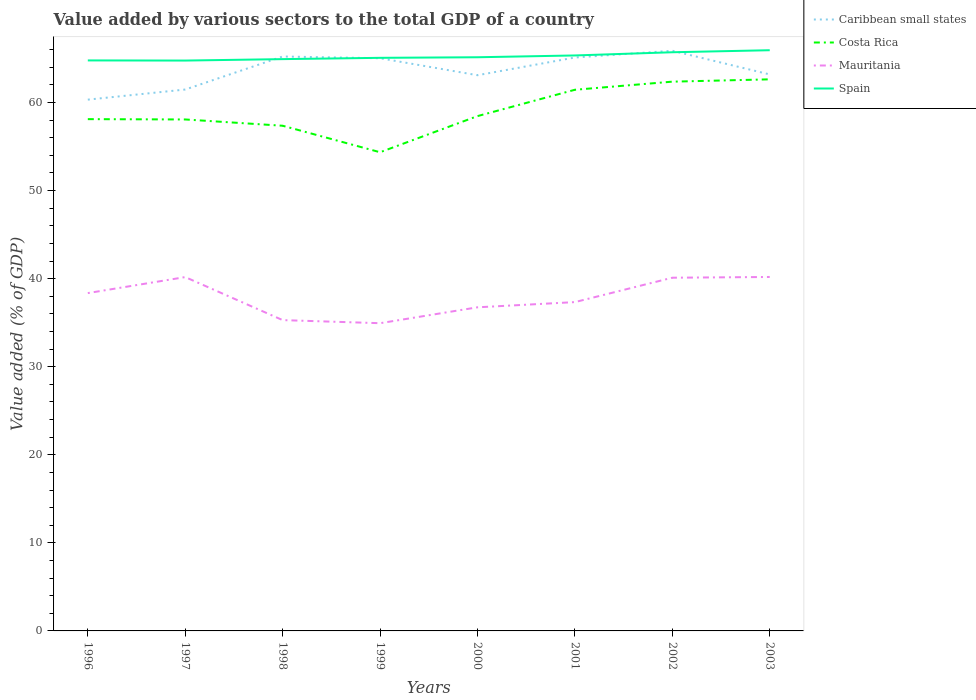How many different coloured lines are there?
Make the answer very short. 4. Is the number of lines equal to the number of legend labels?
Your answer should be compact. Yes. Across all years, what is the maximum value added by various sectors to the total GDP in Mauritania?
Provide a succinct answer. 34.94. In which year was the value added by various sectors to the total GDP in Caribbean small states maximum?
Make the answer very short. 1996. What is the total value added by various sectors to the total GDP in Spain in the graph?
Your answer should be compact. -0.86. What is the difference between the highest and the second highest value added by various sectors to the total GDP in Caribbean small states?
Make the answer very short. 5.55. Is the value added by various sectors to the total GDP in Costa Rica strictly greater than the value added by various sectors to the total GDP in Mauritania over the years?
Provide a succinct answer. No. How many lines are there?
Your answer should be very brief. 4. How many years are there in the graph?
Your answer should be compact. 8. What is the difference between two consecutive major ticks on the Y-axis?
Keep it short and to the point. 10. Does the graph contain any zero values?
Your answer should be very brief. No. How many legend labels are there?
Provide a short and direct response. 4. What is the title of the graph?
Keep it short and to the point. Value added by various sectors to the total GDP of a country. Does "Sub-Saharan Africa (all income levels)" appear as one of the legend labels in the graph?
Give a very brief answer. No. What is the label or title of the Y-axis?
Offer a very short reply. Value added (% of GDP). What is the Value added (% of GDP) of Caribbean small states in 1996?
Offer a terse response. 60.33. What is the Value added (% of GDP) of Costa Rica in 1996?
Offer a very short reply. 58.12. What is the Value added (% of GDP) of Mauritania in 1996?
Offer a terse response. 38.36. What is the Value added (% of GDP) in Spain in 1996?
Provide a short and direct response. 64.78. What is the Value added (% of GDP) in Caribbean small states in 1997?
Your answer should be compact. 61.48. What is the Value added (% of GDP) of Costa Rica in 1997?
Your answer should be compact. 58.08. What is the Value added (% of GDP) of Mauritania in 1997?
Provide a short and direct response. 40.18. What is the Value added (% of GDP) in Spain in 1997?
Give a very brief answer. 64.77. What is the Value added (% of GDP) of Caribbean small states in 1998?
Your answer should be very brief. 65.23. What is the Value added (% of GDP) of Costa Rica in 1998?
Provide a short and direct response. 57.37. What is the Value added (% of GDP) in Mauritania in 1998?
Provide a succinct answer. 35.29. What is the Value added (% of GDP) in Spain in 1998?
Keep it short and to the point. 64.93. What is the Value added (% of GDP) of Caribbean small states in 1999?
Your response must be concise. 65.03. What is the Value added (% of GDP) of Costa Rica in 1999?
Your answer should be compact. 54.36. What is the Value added (% of GDP) of Mauritania in 1999?
Your answer should be very brief. 34.94. What is the Value added (% of GDP) in Spain in 1999?
Ensure brevity in your answer.  65.08. What is the Value added (% of GDP) in Caribbean small states in 2000?
Offer a terse response. 63.1. What is the Value added (% of GDP) in Costa Rica in 2000?
Your answer should be compact. 58.46. What is the Value added (% of GDP) of Mauritania in 2000?
Offer a terse response. 36.75. What is the Value added (% of GDP) in Spain in 2000?
Your answer should be very brief. 65.14. What is the Value added (% of GDP) in Caribbean small states in 2001?
Offer a terse response. 65.11. What is the Value added (% of GDP) of Costa Rica in 2001?
Provide a short and direct response. 61.45. What is the Value added (% of GDP) of Mauritania in 2001?
Offer a terse response. 37.34. What is the Value added (% of GDP) of Spain in 2001?
Your answer should be very brief. 65.35. What is the Value added (% of GDP) in Caribbean small states in 2002?
Ensure brevity in your answer.  65.88. What is the Value added (% of GDP) in Costa Rica in 2002?
Your answer should be compact. 62.37. What is the Value added (% of GDP) of Mauritania in 2002?
Your answer should be compact. 40.11. What is the Value added (% of GDP) in Spain in 2002?
Your response must be concise. 65.71. What is the Value added (% of GDP) in Caribbean small states in 2003?
Offer a very short reply. 63.19. What is the Value added (% of GDP) in Costa Rica in 2003?
Your answer should be compact. 62.64. What is the Value added (% of GDP) in Mauritania in 2003?
Offer a terse response. 40.19. What is the Value added (% of GDP) of Spain in 2003?
Offer a very short reply. 65.94. Across all years, what is the maximum Value added (% of GDP) in Caribbean small states?
Your answer should be compact. 65.88. Across all years, what is the maximum Value added (% of GDP) in Costa Rica?
Offer a terse response. 62.64. Across all years, what is the maximum Value added (% of GDP) of Mauritania?
Your response must be concise. 40.19. Across all years, what is the maximum Value added (% of GDP) of Spain?
Your answer should be very brief. 65.94. Across all years, what is the minimum Value added (% of GDP) in Caribbean small states?
Offer a terse response. 60.33. Across all years, what is the minimum Value added (% of GDP) of Costa Rica?
Give a very brief answer. 54.36. Across all years, what is the minimum Value added (% of GDP) of Mauritania?
Give a very brief answer. 34.94. Across all years, what is the minimum Value added (% of GDP) in Spain?
Provide a short and direct response. 64.77. What is the total Value added (% of GDP) in Caribbean small states in the graph?
Provide a short and direct response. 509.36. What is the total Value added (% of GDP) in Costa Rica in the graph?
Offer a terse response. 472.83. What is the total Value added (% of GDP) in Mauritania in the graph?
Provide a short and direct response. 303.17. What is the total Value added (% of GDP) of Spain in the graph?
Provide a succinct answer. 521.7. What is the difference between the Value added (% of GDP) of Caribbean small states in 1996 and that in 1997?
Provide a succinct answer. -1.15. What is the difference between the Value added (% of GDP) in Costa Rica in 1996 and that in 1997?
Your answer should be compact. 0.04. What is the difference between the Value added (% of GDP) in Mauritania in 1996 and that in 1997?
Provide a short and direct response. -1.82. What is the difference between the Value added (% of GDP) in Spain in 1996 and that in 1997?
Your response must be concise. 0.02. What is the difference between the Value added (% of GDP) in Caribbean small states in 1996 and that in 1998?
Keep it short and to the point. -4.9. What is the difference between the Value added (% of GDP) in Costa Rica in 1996 and that in 1998?
Your answer should be very brief. 0.75. What is the difference between the Value added (% of GDP) in Mauritania in 1996 and that in 1998?
Ensure brevity in your answer.  3.07. What is the difference between the Value added (% of GDP) in Spain in 1996 and that in 1998?
Your response must be concise. -0.15. What is the difference between the Value added (% of GDP) in Caribbean small states in 1996 and that in 1999?
Provide a succinct answer. -4.7. What is the difference between the Value added (% of GDP) of Costa Rica in 1996 and that in 1999?
Keep it short and to the point. 3.76. What is the difference between the Value added (% of GDP) of Mauritania in 1996 and that in 1999?
Ensure brevity in your answer.  3.42. What is the difference between the Value added (% of GDP) in Spain in 1996 and that in 1999?
Keep it short and to the point. -0.29. What is the difference between the Value added (% of GDP) of Caribbean small states in 1996 and that in 2000?
Offer a terse response. -2.77. What is the difference between the Value added (% of GDP) in Costa Rica in 1996 and that in 2000?
Make the answer very short. -0.34. What is the difference between the Value added (% of GDP) of Mauritania in 1996 and that in 2000?
Make the answer very short. 1.61. What is the difference between the Value added (% of GDP) of Spain in 1996 and that in 2000?
Make the answer very short. -0.36. What is the difference between the Value added (% of GDP) of Caribbean small states in 1996 and that in 2001?
Ensure brevity in your answer.  -4.78. What is the difference between the Value added (% of GDP) in Costa Rica in 1996 and that in 2001?
Your response must be concise. -3.34. What is the difference between the Value added (% of GDP) of Spain in 1996 and that in 2001?
Make the answer very short. -0.56. What is the difference between the Value added (% of GDP) in Caribbean small states in 1996 and that in 2002?
Your answer should be very brief. -5.55. What is the difference between the Value added (% of GDP) in Costa Rica in 1996 and that in 2002?
Offer a terse response. -4.26. What is the difference between the Value added (% of GDP) of Mauritania in 1996 and that in 2002?
Provide a short and direct response. -1.75. What is the difference between the Value added (% of GDP) in Spain in 1996 and that in 2002?
Give a very brief answer. -0.93. What is the difference between the Value added (% of GDP) of Caribbean small states in 1996 and that in 2003?
Give a very brief answer. -2.86. What is the difference between the Value added (% of GDP) in Costa Rica in 1996 and that in 2003?
Keep it short and to the point. -4.52. What is the difference between the Value added (% of GDP) in Mauritania in 1996 and that in 2003?
Make the answer very short. -1.83. What is the difference between the Value added (% of GDP) in Spain in 1996 and that in 2003?
Your answer should be very brief. -1.16. What is the difference between the Value added (% of GDP) in Caribbean small states in 1997 and that in 1998?
Give a very brief answer. -3.75. What is the difference between the Value added (% of GDP) in Costa Rica in 1997 and that in 1998?
Offer a very short reply. 0.71. What is the difference between the Value added (% of GDP) in Mauritania in 1997 and that in 1998?
Provide a succinct answer. 4.89. What is the difference between the Value added (% of GDP) in Spain in 1997 and that in 1998?
Make the answer very short. -0.16. What is the difference between the Value added (% of GDP) in Caribbean small states in 1997 and that in 1999?
Ensure brevity in your answer.  -3.55. What is the difference between the Value added (% of GDP) of Costa Rica in 1997 and that in 1999?
Your response must be concise. 3.72. What is the difference between the Value added (% of GDP) of Mauritania in 1997 and that in 1999?
Offer a terse response. 5.24. What is the difference between the Value added (% of GDP) in Spain in 1997 and that in 1999?
Keep it short and to the point. -0.31. What is the difference between the Value added (% of GDP) of Caribbean small states in 1997 and that in 2000?
Provide a succinct answer. -1.62. What is the difference between the Value added (% of GDP) in Costa Rica in 1997 and that in 2000?
Give a very brief answer. -0.38. What is the difference between the Value added (% of GDP) in Mauritania in 1997 and that in 2000?
Your response must be concise. 3.43. What is the difference between the Value added (% of GDP) of Spain in 1997 and that in 2000?
Give a very brief answer. -0.38. What is the difference between the Value added (% of GDP) in Caribbean small states in 1997 and that in 2001?
Your answer should be compact. -3.63. What is the difference between the Value added (% of GDP) of Costa Rica in 1997 and that in 2001?
Offer a very short reply. -3.37. What is the difference between the Value added (% of GDP) in Mauritania in 1997 and that in 2001?
Offer a very short reply. 2.84. What is the difference between the Value added (% of GDP) of Spain in 1997 and that in 2001?
Offer a terse response. -0.58. What is the difference between the Value added (% of GDP) in Caribbean small states in 1997 and that in 2002?
Your response must be concise. -4.4. What is the difference between the Value added (% of GDP) of Costa Rica in 1997 and that in 2002?
Your response must be concise. -4.29. What is the difference between the Value added (% of GDP) of Mauritania in 1997 and that in 2002?
Offer a very short reply. 0.07. What is the difference between the Value added (% of GDP) in Spain in 1997 and that in 2002?
Your answer should be very brief. -0.94. What is the difference between the Value added (% of GDP) of Caribbean small states in 1997 and that in 2003?
Your response must be concise. -1.71. What is the difference between the Value added (% of GDP) in Costa Rica in 1997 and that in 2003?
Offer a terse response. -4.56. What is the difference between the Value added (% of GDP) in Mauritania in 1997 and that in 2003?
Keep it short and to the point. -0.01. What is the difference between the Value added (% of GDP) of Spain in 1997 and that in 2003?
Make the answer very short. -1.17. What is the difference between the Value added (% of GDP) of Caribbean small states in 1998 and that in 1999?
Ensure brevity in your answer.  0.2. What is the difference between the Value added (% of GDP) of Costa Rica in 1998 and that in 1999?
Ensure brevity in your answer.  3.01. What is the difference between the Value added (% of GDP) in Mauritania in 1998 and that in 1999?
Your answer should be compact. 0.35. What is the difference between the Value added (% of GDP) of Spain in 1998 and that in 1999?
Provide a succinct answer. -0.15. What is the difference between the Value added (% of GDP) in Caribbean small states in 1998 and that in 2000?
Make the answer very short. 2.12. What is the difference between the Value added (% of GDP) in Costa Rica in 1998 and that in 2000?
Your answer should be very brief. -1.09. What is the difference between the Value added (% of GDP) in Mauritania in 1998 and that in 2000?
Provide a succinct answer. -1.45. What is the difference between the Value added (% of GDP) in Spain in 1998 and that in 2000?
Provide a succinct answer. -0.21. What is the difference between the Value added (% of GDP) of Caribbean small states in 1998 and that in 2001?
Offer a terse response. 0.11. What is the difference between the Value added (% of GDP) of Costa Rica in 1998 and that in 2001?
Provide a succinct answer. -4.09. What is the difference between the Value added (% of GDP) in Mauritania in 1998 and that in 2001?
Ensure brevity in your answer.  -2.05. What is the difference between the Value added (% of GDP) in Spain in 1998 and that in 2001?
Your answer should be very brief. -0.42. What is the difference between the Value added (% of GDP) in Caribbean small states in 1998 and that in 2002?
Provide a succinct answer. -0.65. What is the difference between the Value added (% of GDP) in Costa Rica in 1998 and that in 2002?
Keep it short and to the point. -5.01. What is the difference between the Value added (% of GDP) of Mauritania in 1998 and that in 2002?
Offer a very short reply. -4.81. What is the difference between the Value added (% of GDP) in Spain in 1998 and that in 2002?
Give a very brief answer. -0.78. What is the difference between the Value added (% of GDP) in Caribbean small states in 1998 and that in 2003?
Offer a terse response. 2.04. What is the difference between the Value added (% of GDP) of Costa Rica in 1998 and that in 2003?
Make the answer very short. -5.27. What is the difference between the Value added (% of GDP) of Mauritania in 1998 and that in 2003?
Your answer should be compact. -4.9. What is the difference between the Value added (% of GDP) in Spain in 1998 and that in 2003?
Ensure brevity in your answer.  -1.01. What is the difference between the Value added (% of GDP) in Caribbean small states in 1999 and that in 2000?
Provide a short and direct response. 1.93. What is the difference between the Value added (% of GDP) of Costa Rica in 1999 and that in 2000?
Your answer should be compact. -4.1. What is the difference between the Value added (% of GDP) of Mauritania in 1999 and that in 2000?
Offer a very short reply. -1.8. What is the difference between the Value added (% of GDP) in Spain in 1999 and that in 2000?
Your answer should be very brief. -0.07. What is the difference between the Value added (% of GDP) in Caribbean small states in 1999 and that in 2001?
Ensure brevity in your answer.  -0.08. What is the difference between the Value added (% of GDP) of Costa Rica in 1999 and that in 2001?
Keep it short and to the point. -7.1. What is the difference between the Value added (% of GDP) of Mauritania in 1999 and that in 2001?
Offer a very short reply. -2.4. What is the difference between the Value added (% of GDP) of Spain in 1999 and that in 2001?
Offer a very short reply. -0.27. What is the difference between the Value added (% of GDP) in Caribbean small states in 1999 and that in 2002?
Provide a succinct answer. -0.85. What is the difference between the Value added (% of GDP) in Costa Rica in 1999 and that in 2002?
Your response must be concise. -8.02. What is the difference between the Value added (% of GDP) of Mauritania in 1999 and that in 2002?
Offer a very short reply. -5.17. What is the difference between the Value added (% of GDP) in Spain in 1999 and that in 2002?
Provide a succinct answer. -0.63. What is the difference between the Value added (% of GDP) of Caribbean small states in 1999 and that in 2003?
Offer a terse response. 1.84. What is the difference between the Value added (% of GDP) in Costa Rica in 1999 and that in 2003?
Your answer should be compact. -8.28. What is the difference between the Value added (% of GDP) in Mauritania in 1999 and that in 2003?
Your response must be concise. -5.25. What is the difference between the Value added (% of GDP) of Spain in 1999 and that in 2003?
Ensure brevity in your answer.  -0.86. What is the difference between the Value added (% of GDP) of Caribbean small states in 2000 and that in 2001?
Your response must be concise. -2.01. What is the difference between the Value added (% of GDP) of Costa Rica in 2000 and that in 2001?
Provide a succinct answer. -2.99. What is the difference between the Value added (% of GDP) in Mauritania in 2000 and that in 2001?
Ensure brevity in your answer.  -0.59. What is the difference between the Value added (% of GDP) in Spain in 2000 and that in 2001?
Ensure brevity in your answer.  -0.2. What is the difference between the Value added (% of GDP) in Caribbean small states in 2000 and that in 2002?
Ensure brevity in your answer.  -2.78. What is the difference between the Value added (% of GDP) in Costa Rica in 2000 and that in 2002?
Ensure brevity in your answer.  -3.91. What is the difference between the Value added (% of GDP) in Mauritania in 2000 and that in 2002?
Make the answer very short. -3.36. What is the difference between the Value added (% of GDP) of Spain in 2000 and that in 2002?
Keep it short and to the point. -0.57. What is the difference between the Value added (% of GDP) of Caribbean small states in 2000 and that in 2003?
Your answer should be very brief. -0.09. What is the difference between the Value added (% of GDP) in Costa Rica in 2000 and that in 2003?
Keep it short and to the point. -4.18. What is the difference between the Value added (% of GDP) in Mauritania in 2000 and that in 2003?
Your answer should be very brief. -3.44. What is the difference between the Value added (% of GDP) of Spain in 2000 and that in 2003?
Give a very brief answer. -0.8. What is the difference between the Value added (% of GDP) in Caribbean small states in 2001 and that in 2002?
Offer a very short reply. -0.77. What is the difference between the Value added (% of GDP) in Costa Rica in 2001 and that in 2002?
Your response must be concise. -0.92. What is the difference between the Value added (% of GDP) of Mauritania in 2001 and that in 2002?
Offer a very short reply. -2.77. What is the difference between the Value added (% of GDP) in Spain in 2001 and that in 2002?
Offer a very short reply. -0.36. What is the difference between the Value added (% of GDP) of Caribbean small states in 2001 and that in 2003?
Provide a short and direct response. 1.92. What is the difference between the Value added (% of GDP) of Costa Rica in 2001 and that in 2003?
Your response must be concise. -1.18. What is the difference between the Value added (% of GDP) in Mauritania in 2001 and that in 2003?
Keep it short and to the point. -2.85. What is the difference between the Value added (% of GDP) in Spain in 2001 and that in 2003?
Provide a short and direct response. -0.59. What is the difference between the Value added (% of GDP) in Caribbean small states in 2002 and that in 2003?
Offer a very short reply. 2.69. What is the difference between the Value added (% of GDP) in Costa Rica in 2002 and that in 2003?
Keep it short and to the point. -0.26. What is the difference between the Value added (% of GDP) of Mauritania in 2002 and that in 2003?
Your answer should be very brief. -0.08. What is the difference between the Value added (% of GDP) of Spain in 2002 and that in 2003?
Your answer should be compact. -0.23. What is the difference between the Value added (% of GDP) in Caribbean small states in 1996 and the Value added (% of GDP) in Costa Rica in 1997?
Keep it short and to the point. 2.25. What is the difference between the Value added (% of GDP) in Caribbean small states in 1996 and the Value added (% of GDP) in Mauritania in 1997?
Provide a succinct answer. 20.15. What is the difference between the Value added (% of GDP) in Caribbean small states in 1996 and the Value added (% of GDP) in Spain in 1997?
Your answer should be compact. -4.44. What is the difference between the Value added (% of GDP) of Costa Rica in 1996 and the Value added (% of GDP) of Mauritania in 1997?
Your answer should be very brief. 17.94. What is the difference between the Value added (% of GDP) of Costa Rica in 1996 and the Value added (% of GDP) of Spain in 1997?
Your answer should be very brief. -6.65. What is the difference between the Value added (% of GDP) in Mauritania in 1996 and the Value added (% of GDP) in Spain in 1997?
Offer a very short reply. -26.41. What is the difference between the Value added (% of GDP) of Caribbean small states in 1996 and the Value added (% of GDP) of Costa Rica in 1998?
Provide a succinct answer. 2.96. What is the difference between the Value added (% of GDP) in Caribbean small states in 1996 and the Value added (% of GDP) in Mauritania in 1998?
Provide a succinct answer. 25.04. What is the difference between the Value added (% of GDP) of Caribbean small states in 1996 and the Value added (% of GDP) of Spain in 1998?
Provide a short and direct response. -4.6. What is the difference between the Value added (% of GDP) of Costa Rica in 1996 and the Value added (% of GDP) of Mauritania in 1998?
Your answer should be very brief. 22.82. What is the difference between the Value added (% of GDP) in Costa Rica in 1996 and the Value added (% of GDP) in Spain in 1998?
Offer a terse response. -6.82. What is the difference between the Value added (% of GDP) of Mauritania in 1996 and the Value added (% of GDP) of Spain in 1998?
Give a very brief answer. -26.57. What is the difference between the Value added (% of GDP) in Caribbean small states in 1996 and the Value added (% of GDP) in Costa Rica in 1999?
Your answer should be compact. 5.97. What is the difference between the Value added (% of GDP) in Caribbean small states in 1996 and the Value added (% of GDP) in Mauritania in 1999?
Provide a short and direct response. 25.39. What is the difference between the Value added (% of GDP) of Caribbean small states in 1996 and the Value added (% of GDP) of Spain in 1999?
Your answer should be compact. -4.75. What is the difference between the Value added (% of GDP) in Costa Rica in 1996 and the Value added (% of GDP) in Mauritania in 1999?
Make the answer very short. 23.17. What is the difference between the Value added (% of GDP) in Costa Rica in 1996 and the Value added (% of GDP) in Spain in 1999?
Give a very brief answer. -6.96. What is the difference between the Value added (% of GDP) of Mauritania in 1996 and the Value added (% of GDP) of Spain in 1999?
Make the answer very short. -26.72. What is the difference between the Value added (% of GDP) in Caribbean small states in 1996 and the Value added (% of GDP) in Costa Rica in 2000?
Ensure brevity in your answer.  1.87. What is the difference between the Value added (% of GDP) in Caribbean small states in 1996 and the Value added (% of GDP) in Mauritania in 2000?
Provide a short and direct response. 23.58. What is the difference between the Value added (% of GDP) in Caribbean small states in 1996 and the Value added (% of GDP) in Spain in 2000?
Provide a short and direct response. -4.81. What is the difference between the Value added (% of GDP) in Costa Rica in 1996 and the Value added (% of GDP) in Mauritania in 2000?
Give a very brief answer. 21.37. What is the difference between the Value added (% of GDP) in Costa Rica in 1996 and the Value added (% of GDP) in Spain in 2000?
Keep it short and to the point. -7.03. What is the difference between the Value added (% of GDP) in Mauritania in 1996 and the Value added (% of GDP) in Spain in 2000?
Your answer should be compact. -26.78. What is the difference between the Value added (% of GDP) in Caribbean small states in 1996 and the Value added (% of GDP) in Costa Rica in 2001?
Offer a very short reply. -1.12. What is the difference between the Value added (% of GDP) in Caribbean small states in 1996 and the Value added (% of GDP) in Mauritania in 2001?
Your answer should be compact. 22.99. What is the difference between the Value added (% of GDP) of Caribbean small states in 1996 and the Value added (% of GDP) of Spain in 2001?
Keep it short and to the point. -5.02. What is the difference between the Value added (% of GDP) in Costa Rica in 1996 and the Value added (% of GDP) in Mauritania in 2001?
Provide a succinct answer. 20.78. What is the difference between the Value added (% of GDP) of Costa Rica in 1996 and the Value added (% of GDP) of Spain in 2001?
Provide a short and direct response. -7.23. What is the difference between the Value added (% of GDP) of Mauritania in 1996 and the Value added (% of GDP) of Spain in 2001?
Provide a short and direct response. -26.99. What is the difference between the Value added (% of GDP) in Caribbean small states in 1996 and the Value added (% of GDP) in Costa Rica in 2002?
Your response must be concise. -2.04. What is the difference between the Value added (% of GDP) in Caribbean small states in 1996 and the Value added (% of GDP) in Mauritania in 2002?
Ensure brevity in your answer.  20.22. What is the difference between the Value added (% of GDP) of Caribbean small states in 1996 and the Value added (% of GDP) of Spain in 2002?
Provide a short and direct response. -5.38. What is the difference between the Value added (% of GDP) of Costa Rica in 1996 and the Value added (% of GDP) of Mauritania in 2002?
Offer a very short reply. 18.01. What is the difference between the Value added (% of GDP) in Costa Rica in 1996 and the Value added (% of GDP) in Spain in 2002?
Your answer should be compact. -7.6. What is the difference between the Value added (% of GDP) of Mauritania in 1996 and the Value added (% of GDP) of Spain in 2002?
Keep it short and to the point. -27.35. What is the difference between the Value added (% of GDP) of Caribbean small states in 1996 and the Value added (% of GDP) of Costa Rica in 2003?
Your answer should be very brief. -2.31. What is the difference between the Value added (% of GDP) of Caribbean small states in 1996 and the Value added (% of GDP) of Mauritania in 2003?
Offer a terse response. 20.14. What is the difference between the Value added (% of GDP) in Caribbean small states in 1996 and the Value added (% of GDP) in Spain in 2003?
Ensure brevity in your answer.  -5.61. What is the difference between the Value added (% of GDP) of Costa Rica in 1996 and the Value added (% of GDP) of Mauritania in 2003?
Offer a very short reply. 17.92. What is the difference between the Value added (% of GDP) in Costa Rica in 1996 and the Value added (% of GDP) in Spain in 2003?
Your response must be concise. -7.83. What is the difference between the Value added (% of GDP) in Mauritania in 1996 and the Value added (% of GDP) in Spain in 2003?
Provide a short and direct response. -27.58. What is the difference between the Value added (% of GDP) in Caribbean small states in 1997 and the Value added (% of GDP) in Costa Rica in 1998?
Ensure brevity in your answer.  4.11. What is the difference between the Value added (% of GDP) of Caribbean small states in 1997 and the Value added (% of GDP) of Mauritania in 1998?
Offer a very short reply. 26.19. What is the difference between the Value added (% of GDP) in Caribbean small states in 1997 and the Value added (% of GDP) in Spain in 1998?
Keep it short and to the point. -3.45. What is the difference between the Value added (% of GDP) of Costa Rica in 1997 and the Value added (% of GDP) of Mauritania in 1998?
Offer a terse response. 22.79. What is the difference between the Value added (% of GDP) of Costa Rica in 1997 and the Value added (% of GDP) of Spain in 1998?
Offer a very short reply. -6.85. What is the difference between the Value added (% of GDP) in Mauritania in 1997 and the Value added (% of GDP) in Spain in 1998?
Ensure brevity in your answer.  -24.75. What is the difference between the Value added (% of GDP) of Caribbean small states in 1997 and the Value added (% of GDP) of Costa Rica in 1999?
Keep it short and to the point. 7.12. What is the difference between the Value added (% of GDP) in Caribbean small states in 1997 and the Value added (% of GDP) in Mauritania in 1999?
Your response must be concise. 26.54. What is the difference between the Value added (% of GDP) in Caribbean small states in 1997 and the Value added (% of GDP) in Spain in 1999?
Ensure brevity in your answer.  -3.6. What is the difference between the Value added (% of GDP) in Costa Rica in 1997 and the Value added (% of GDP) in Mauritania in 1999?
Offer a terse response. 23.14. What is the difference between the Value added (% of GDP) of Costa Rica in 1997 and the Value added (% of GDP) of Spain in 1999?
Provide a succinct answer. -7. What is the difference between the Value added (% of GDP) of Mauritania in 1997 and the Value added (% of GDP) of Spain in 1999?
Make the answer very short. -24.9. What is the difference between the Value added (% of GDP) of Caribbean small states in 1997 and the Value added (% of GDP) of Costa Rica in 2000?
Offer a very short reply. 3.02. What is the difference between the Value added (% of GDP) in Caribbean small states in 1997 and the Value added (% of GDP) in Mauritania in 2000?
Offer a very short reply. 24.73. What is the difference between the Value added (% of GDP) in Caribbean small states in 1997 and the Value added (% of GDP) in Spain in 2000?
Provide a short and direct response. -3.67. What is the difference between the Value added (% of GDP) in Costa Rica in 1997 and the Value added (% of GDP) in Mauritania in 2000?
Provide a short and direct response. 21.33. What is the difference between the Value added (% of GDP) in Costa Rica in 1997 and the Value added (% of GDP) in Spain in 2000?
Your response must be concise. -7.07. What is the difference between the Value added (% of GDP) of Mauritania in 1997 and the Value added (% of GDP) of Spain in 2000?
Offer a terse response. -24.96. What is the difference between the Value added (% of GDP) in Caribbean small states in 1997 and the Value added (% of GDP) in Costa Rica in 2001?
Provide a succinct answer. 0.03. What is the difference between the Value added (% of GDP) in Caribbean small states in 1997 and the Value added (% of GDP) in Mauritania in 2001?
Your answer should be very brief. 24.14. What is the difference between the Value added (% of GDP) in Caribbean small states in 1997 and the Value added (% of GDP) in Spain in 2001?
Provide a short and direct response. -3.87. What is the difference between the Value added (% of GDP) of Costa Rica in 1997 and the Value added (% of GDP) of Mauritania in 2001?
Your answer should be compact. 20.74. What is the difference between the Value added (% of GDP) in Costa Rica in 1997 and the Value added (% of GDP) in Spain in 2001?
Offer a terse response. -7.27. What is the difference between the Value added (% of GDP) of Mauritania in 1997 and the Value added (% of GDP) of Spain in 2001?
Give a very brief answer. -25.17. What is the difference between the Value added (% of GDP) in Caribbean small states in 1997 and the Value added (% of GDP) in Costa Rica in 2002?
Your response must be concise. -0.89. What is the difference between the Value added (% of GDP) of Caribbean small states in 1997 and the Value added (% of GDP) of Mauritania in 2002?
Offer a terse response. 21.37. What is the difference between the Value added (% of GDP) of Caribbean small states in 1997 and the Value added (% of GDP) of Spain in 2002?
Keep it short and to the point. -4.23. What is the difference between the Value added (% of GDP) of Costa Rica in 1997 and the Value added (% of GDP) of Mauritania in 2002?
Provide a succinct answer. 17.97. What is the difference between the Value added (% of GDP) of Costa Rica in 1997 and the Value added (% of GDP) of Spain in 2002?
Provide a short and direct response. -7.63. What is the difference between the Value added (% of GDP) of Mauritania in 1997 and the Value added (% of GDP) of Spain in 2002?
Keep it short and to the point. -25.53. What is the difference between the Value added (% of GDP) of Caribbean small states in 1997 and the Value added (% of GDP) of Costa Rica in 2003?
Provide a short and direct response. -1.16. What is the difference between the Value added (% of GDP) of Caribbean small states in 1997 and the Value added (% of GDP) of Mauritania in 2003?
Your response must be concise. 21.29. What is the difference between the Value added (% of GDP) of Caribbean small states in 1997 and the Value added (% of GDP) of Spain in 2003?
Ensure brevity in your answer.  -4.46. What is the difference between the Value added (% of GDP) in Costa Rica in 1997 and the Value added (% of GDP) in Mauritania in 2003?
Your response must be concise. 17.89. What is the difference between the Value added (% of GDP) of Costa Rica in 1997 and the Value added (% of GDP) of Spain in 2003?
Your answer should be compact. -7.86. What is the difference between the Value added (% of GDP) of Mauritania in 1997 and the Value added (% of GDP) of Spain in 2003?
Ensure brevity in your answer.  -25.76. What is the difference between the Value added (% of GDP) of Caribbean small states in 1998 and the Value added (% of GDP) of Costa Rica in 1999?
Give a very brief answer. 10.87. What is the difference between the Value added (% of GDP) in Caribbean small states in 1998 and the Value added (% of GDP) in Mauritania in 1999?
Offer a terse response. 30.28. What is the difference between the Value added (% of GDP) of Costa Rica in 1998 and the Value added (% of GDP) of Mauritania in 1999?
Offer a very short reply. 22.42. What is the difference between the Value added (% of GDP) of Costa Rica in 1998 and the Value added (% of GDP) of Spain in 1999?
Give a very brief answer. -7.71. What is the difference between the Value added (% of GDP) of Mauritania in 1998 and the Value added (% of GDP) of Spain in 1999?
Ensure brevity in your answer.  -29.78. What is the difference between the Value added (% of GDP) in Caribbean small states in 1998 and the Value added (% of GDP) in Costa Rica in 2000?
Your response must be concise. 6.77. What is the difference between the Value added (% of GDP) of Caribbean small states in 1998 and the Value added (% of GDP) of Mauritania in 2000?
Ensure brevity in your answer.  28.48. What is the difference between the Value added (% of GDP) in Caribbean small states in 1998 and the Value added (% of GDP) in Spain in 2000?
Offer a terse response. 0.08. What is the difference between the Value added (% of GDP) of Costa Rica in 1998 and the Value added (% of GDP) of Mauritania in 2000?
Your answer should be very brief. 20.62. What is the difference between the Value added (% of GDP) in Costa Rica in 1998 and the Value added (% of GDP) in Spain in 2000?
Offer a very short reply. -7.78. What is the difference between the Value added (% of GDP) in Mauritania in 1998 and the Value added (% of GDP) in Spain in 2000?
Give a very brief answer. -29.85. What is the difference between the Value added (% of GDP) in Caribbean small states in 1998 and the Value added (% of GDP) in Costa Rica in 2001?
Your answer should be very brief. 3.78. What is the difference between the Value added (% of GDP) in Caribbean small states in 1998 and the Value added (% of GDP) in Mauritania in 2001?
Provide a succinct answer. 27.89. What is the difference between the Value added (% of GDP) of Caribbean small states in 1998 and the Value added (% of GDP) of Spain in 2001?
Your response must be concise. -0.12. What is the difference between the Value added (% of GDP) in Costa Rica in 1998 and the Value added (% of GDP) in Mauritania in 2001?
Make the answer very short. 20.03. What is the difference between the Value added (% of GDP) in Costa Rica in 1998 and the Value added (% of GDP) in Spain in 2001?
Give a very brief answer. -7.98. What is the difference between the Value added (% of GDP) in Mauritania in 1998 and the Value added (% of GDP) in Spain in 2001?
Your response must be concise. -30.05. What is the difference between the Value added (% of GDP) in Caribbean small states in 1998 and the Value added (% of GDP) in Costa Rica in 2002?
Offer a terse response. 2.86. What is the difference between the Value added (% of GDP) in Caribbean small states in 1998 and the Value added (% of GDP) in Mauritania in 2002?
Your answer should be very brief. 25.12. What is the difference between the Value added (% of GDP) of Caribbean small states in 1998 and the Value added (% of GDP) of Spain in 2002?
Your response must be concise. -0.48. What is the difference between the Value added (% of GDP) in Costa Rica in 1998 and the Value added (% of GDP) in Mauritania in 2002?
Provide a short and direct response. 17.26. What is the difference between the Value added (% of GDP) of Costa Rica in 1998 and the Value added (% of GDP) of Spain in 2002?
Your answer should be very brief. -8.35. What is the difference between the Value added (% of GDP) of Mauritania in 1998 and the Value added (% of GDP) of Spain in 2002?
Make the answer very short. -30.42. What is the difference between the Value added (% of GDP) of Caribbean small states in 1998 and the Value added (% of GDP) of Costa Rica in 2003?
Your answer should be very brief. 2.59. What is the difference between the Value added (% of GDP) in Caribbean small states in 1998 and the Value added (% of GDP) in Mauritania in 2003?
Ensure brevity in your answer.  25.04. What is the difference between the Value added (% of GDP) of Caribbean small states in 1998 and the Value added (% of GDP) of Spain in 2003?
Give a very brief answer. -0.71. What is the difference between the Value added (% of GDP) in Costa Rica in 1998 and the Value added (% of GDP) in Mauritania in 2003?
Make the answer very short. 17.17. What is the difference between the Value added (% of GDP) of Costa Rica in 1998 and the Value added (% of GDP) of Spain in 2003?
Give a very brief answer. -8.58. What is the difference between the Value added (% of GDP) of Mauritania in 1998 and the Value added (% of GDP) of Spain in 2003?
Your answer should be compact. -30.65. What is the difference between the Value added (% of GDP) of Caribbean small states in 1999 and the Value added (% of GDP) of Costa Rica in 2000?
Your answer should be very brief. 6.57. What is the difference between the Value added (% of GDP) of Caribbean small states in 1999 and the Value added (% of GDP) of Mauritania in 2000?
Offer a terse response. 28.28. What is the difference between the Value added (% of GDP) of Caribbean small states in 1999 and the Value added (% of GDP) of Spain in 2000?
Provide a succinct answer. -0.11. What is the difference between the Value added (% of GDP) in Costa Rica in 1999 and the Value added (% of GDP) in Mauritania in 2000?
Your answer should be very brief. 17.61. What is the difference between the Value added (% of GDP) of Costa Rica in 1999 and the Value added (% of GDP) of Spain in 2000?
Offer a very short reply. -10.79. What is the difference between the Value added (% of GDP) in Mauritania in 1999 and the Value added (% of GDP) in Spain in 2000?
Make the answer very short. -30.2. What is the difference between the Value added (% of GDP) in Caribbean small states in 1999 and the Value added (% of GDP) in Costa Rica in 2001?
Offer a very short reply. 3.58. What is the difference between the Value added (% of GDP) of Caribbean small states in 1999 and the Value added (% of GDP) of Mauritania in 2001?
Keep it short and to the point. 27.69. What is the difference between the Value added (% of GDP) of Caribbean small states in 1999 and the Value added (% of GDP) of Spain in 2001?
Offer a terse response. -0.32. What is the difference between the Value added (% of GDP) in Costa Rica in 1999 and the Value added (% of GDP) in Mauritania in 2001?
Keep it short and to the point. 17.02. What is the difference between the Value added (% of GDP) in Costa Rica in 1999 and the Value added (% of GDP) in Spain in 2001?
Ensure brevity in your answer.  -10.99. What is the difference between the Value added (% of GDP) of Mauritania in 1999 and the Value added (% of GDP) of Spain in 2001?
Provide a succinct answer. -30.4. What is the difference between the Value added (% of GDP) of Caribbean small states in 1999 and the Value added (% of GDP) of Costa Rica in 2002?
Offer a terse response. 2.66. What is the difference between the Value added (% of GDP) in Caribbean small states in 1999 and the Value added (% of GDP) in Mauritania in 2002?
Provide a short and direct response. 24.92. What is the difference between the Value added (% of GDP) in Caribbean small states in 1999 and the Value added (% of GDP) in Spain in 2002?
Keep it short and to the point. -0.68. What is the difference between the Value added (% of GDP) of Costa Rica in 1999 and the Value added (% of GDP) of Mauritania in 2002?
Provide a succinct answer. 14.25. What is the difference between the Value added (% of GDP) in Costa Rica in 1999 and the Value added (% of GDP) in Spain in 2002?
Your answer should be very brief. -11.36. What is the difference between the Value added (% of GDP) of Mauritania in 1999 and the Value added (% of GDP) of Spain in 2002?
Your answer should be very brief. -30.77. What is the difference between the Value added (% of GDP) of Caribbean small states in 1999 and the Value added (% of GDP) of Costa Rica in 2003?
Ensure brevity in your answer.  2.39. What is the difference between the Value added (% of GDP) in Caribbean small states in 1999 and the Value added (% of GDP) in Mauritania in 2003?
Give a very brief answer. 24.84. What is the difference between the Value added (% of GDP) in Caribbean small states in 1999 and the Value added (% of GDP) in Spain in 2003?
Offer a very short reply. -0.91. What is the difference between the Value added (% of GDP) in Costa Rica in 1999 and the Value added (% of GDP) in Mauritania in 2003?
Provide a succinct answer. 14.16. What is the difference between the Value added (% of GDP) in Costa Rica in 1999 and the Value added (% of GDP) in Spain in 2003?
Provide a succinct answer. -11.59. What is the difference between the Value added (% of GDP) of Mauritania in 1999 and the Value added (% of GDP) of Spain in 2003?
Give a very brief answer. -31. What is the difference between the Value added (% of GDP) of Caribbean small states in 2000 and the Value added (% of GDP) of Costa Rica in 2001?
Your answer should be compact. 1.65. What is the difference between the Value added (% of GDP) in Caribbean small states in 2000 and the Value added (% of GDP) in Mauritania in 2001?
Give a very brief answer. 25.76. What is the difference between the Value added (% of GDP) in Caribbean small states in 2000 and the Value added (% of GDP) in Spain in 2001?
Keep it short and to the point. -2.24. What is the difference between the Value added (% of GDP) in Costa Rica in 2000 and the Value added (% of GDP) in Mauritania in 2001?
Offer a terse response. 21.12. What is the difference between the Value added (% of GDP) of Costa Rica in 2000 and the Value added (% of GDP) of Spain in 2001?
Your response must be concise. -6.89. What is the difference between the Value added (% of GDP) of Mauritania in 2000 and the Value added (% of GDP) of Spain in 2001?
Give a very brief answer. -28.6. What is the difference between the Value added (% of GDP) in Caribbean small states in 2000 and the Value added (% of GDP) in Costa Rica in 2002?
Your response must be concise. 0.73. What is the difference between the Value added (% of GDP) in Caribbean small states in 2000 and the Value added (% of GDP) in Mauritania in 2002?
Provide a succinct answer. 22.99. What is the difference between the Value added (% of GDP) in Caribbean small states in 2000 and the Value added (% of GDP) in Spain in 2002?
Keep it short and to the point. -2.61. What is the difference between the Value added (% of GDP) of Costa Rica in 2000 and the Value added (% of GDP) of Mauritania in 2002?
Make the answer very short. 18.35. What is the difference between the Value added (% of GDP) in Costa Rica in 2000 and the Value added (% of GDP) in Spain in 2002?
Provide a succinct answer. -7.25. What is the difference between the Value added (% of GDP) of Mauritania in 2000 and the Value added (% of GDP) of Spain in 2002?
Provide a short and direct response. -28.96. What is the difference between the Value added (% of GDP) in Caribbean small states in 2000 and the Value added (% of GDP) in Costa Rica in 2003?
Give a very brief answer. 0.47. What is the difference between the Value added (% of GDP) of Caribbean small states in 2000 and the Value added (% of GDP) of Mauritania in 2003?
Offer a very short reply. 22.91. What is the difference between the Value added (% of GDP) in Caribbean small states in 2000 and the Value added (% of GDP) in Spain in 2003?
Make the answer very short. -2.84. What is the difference between the Value added (% of GDP) of Costa Rica in 2000 and the Value added (% of GDP) of Mauritania in 2003?
Your response must be concise. 18.27. What is the difference between the Value added (% of GDP) of Costa Rica in 2000 and the Value added (% of GDP) of Spain in 2003?
Make the answer very short. -7.48. What is the difference between the Value added (% of GDP) in Mauritania in 2000 and the Value added (% of GDP) in Spain in 2003?
Provide a short and direct response. -29.19. What is the difference between the Value added (% of GDP) of Caribbean small states in 2001 and the Value added (% of GDP) of Costa Rica in 2002?
Provide a succinct answer. 2.74. What is the difference between the Value added (% of GDP) of Caribbean small states in 2001 and the Value added (% of GDP) of Mauritania in 2002?
Offer a terse response. 25. What is the difference between the Value added (% of GDP) of Caribbean small states in 2001 and the Value added (% of GDP) of Spain in 2002?
Keep it short and to the point. -0.6. What is the difference between the Value added (% of GDP) of Costa Rica in 2001 and the Value added (% of GDP) of Mauritania in 2002?
Make the answer very short. 21.34. What is the difference between the Value added (% of GDP) in Costa Rica in 2001 and the Value added (% of GDP) in Spain in 2002?
Offer a very short reply. -4.26. What is the difference between the Value added (% of GDP) of Mauritania in 2001 and the Value added (% of GDP) of Spain in 2002?
Offer a terse response. -28.37. What is the difference between the Value added (% of GDP) of Caribbean small states in 2001 and the Value added (% of GDP) of Costa Rica in 2003?
Your answer should be compact. 2.48. What is the difference between the Value added (% of GDP) in Caribbean small states in 2001 and the Value added (% of GDP) in Mauritania in 2003?
Give a very brief answer. 24.92. What is the difference between the Value added (% of GDP) in Caribbean small states in 2001 and the Value added (% of GDP) in Spain in 2003?
Your answer should be compact. -0.83. What is the difference between the Value added (% of GDP) in Costa Rica in 2001 and the Value added (% of GDP) in Mauritania in 2003?
Give a very brief answer. 21.26. What is the difference between the Value added (% of GDP) of Costa Rica in 2001 and the Value added (% of GDP) of Spain in 2003?
Provide a short and direct response. -4.49. What is the difference between the Value added (% of GDP) in Mauritania in 2001 and the Value added (% of GDP) in Spain in 2003?
Ensure brevity in your answer.  -28.6. What is the difference between the Value added (% of GDP) in Caribbean small states in 2002 and the Value added (% of GDP) in Costa Rica in 2003?
Provide a succinct answer. 3.25. What is the difference between the Value added (% of GDP) of Caribbean small states in 2002 and the Value added (% of GDP) of Mauritania in 2003?
Your response must be concise. 25.69. What is the difference between the Value added (% of GDP) of Caribbean small states in 2002 and the Value added (% of GDP) of Spain in 2003?
Offer a terse response. -0.06. What is the difference between the Value added (% of GDP) in Costa Rica in 2002 and the Value added (% of GDP) in Mauritania in 2003?
Your answer should be very brief. 22.18. What is the difference between the Value added (% of GDP) in Costa Rica in 2002 and the Value added (% of GDP) in Spain in 2003?
Provide a succinct answer. -3.57. What is the difference between the Value added (% of GDP) of Mauritania in 2002 and the Value added (% of GDP) of Spain in 2003?
Your response must be concise. -25.83. What is the average Value added (% of GDP) in Caribbean small states per year?
Your answer should be compact. 63.67. What is the average Value added (% of GDP) in Costa Rica per year?
Offer a very short reply. 59.1. What is the average Value added (% of GDP) of Mauritania per year?
Ensure brevity in your answer.  37.9. What is the average Value added (% of GDP) in Spain per year?
Your response must be concise. 65.21. In the year 1996, what is the difference between the Value added (% of GDP) in Caribbean small states and Value added (% of GDP) in Costa Rica?
Ensure brevity in your answer.  2.21. In the year 1996, what is the difference between the Value added (% of GDP) of Caribbean small states and Value added (% of GDP) of Mauritania?
Give a very brief answer. 21.97. In the year 1996, what is the difference between the Value added (% of GDP) of Caribbean small states and Value added (% of GDP) of Spain?
Your answer should be compact. -4.45. In the year 1996, what is the difference between the Value added (% of GDP) in Costa Rica and Value added (% of GDP) in Mauritania?
Make the answer very short. 19.75. In the year 1996, what is the difference between the Value added (% of GDP) of Costa Rica and Value added (% of GDP) of Spain?
Make the answer very short. -6.67. In the year 1996, what is the difference between the Value added (% of GDP) of Mauritania and Value added (% of GDP) of Spain?
Ensure brevity in your answer.  -26.42. In the year 1997, what is the difference between the Value added (% of GDP) of Caribbean small states and Value added (% of GDP) of Costa Rica?
Ensure brevity in your answer.  3.4. In the year 1997, what is the difference between the Value added (% of GDP) of Caribbean small states and Value added (% of GDP) of Mauritania?
Provide a succinct answer. 21.3. In the year 1997, what is the difference between the Value added (% of GDP) in Caribbean small states and Value added (% of GDP) in Spain?
Offer a very short reply. -3.29. In the year 1997, what is the difference between the Value added (% of GDP) in Costa Rica and Value added (% of GDP) in Mauritania?
Give a very brief answer. 17.9. In the year 1997, what is the difference between the Value added (% of GDP) in Costa Rica and Value added (% of GDP) in Spain?
Make the answer very short. -6.69. In the year 1997, what is the difference between the Value added (% of GDP) of Mauritania and Value added (% of GDP) of Spain?
Your answer should be compact. -24.59. In the year 1998, what is the difference between the Value added (% of GDP) of Caribbean small states and Value added (% of GDP) of Costa Rica?
Keep it short and to the point. 7.86. In the year 1998, what is the difference between the Value added (% of GDP) in Caribbean small states and Value added (% of GDP) in Mauritania?
Make the answer very short. 29.93. In the year 1998, what is the difference between the Value added (% of GDP) of Caribbean small states and Value added (% of GDP) of Spain?
Your answer should be compact. 0.3. In the year 1998, what is the difference between the Value added (% of GDP) in Costa Rica and Value added (% of GDP) in Mauritania?
Provide a short and direct response. 22.07. In the year 1998, what is the difference between the Value added (% of GDP) of Costa Rica and Value added (% of GDP) of Spain?
Your answer should be compact. -7.57. In the year 1998, what is the difference between the Value added (% of GDP) of Mauritania and Value added (% of GDP) of Spain?
Offer a terse response. -29.64. In the year 1999, what is the difference between the Value added (% of GDP) in Caribbean small states and Value added (% of GDP) in Costa Rica?
Give a very brief answer. 10.67. In the year 1999, what is the difference between the Value added (% of GDP) of Caribbean small states and Value added (% of GDP) of Mauritania?
Offer a very short reply. 30.09. In the year 1999, what is the difference between the Value added (% of GDP) of Caribbean small states and Value added (% of GDP) of Spain?
Your answer should be very brief. -0.05. In the year 1999, what is the difference between the Value added (% of GDP) in Costa Rica and Value added (% of GDP) in Mauritania?
Keep it short and to the point. 19.41. In the year 1999, what is the difference between the Value added (% of GDP) of Costa Rica and Value added (% of GDP) of Spain?
Ensure brevity in your answer.  -10.72. In the year 1999, what is the difference between the Value added (% of GDP) of Mauritania and Value added (% of GDP) of Spain?
Your answer should be compact. -30.13. In the year 2000, what is the difference between the Value added (% of GDP) in Caribbean small states and Value added (% of GDP) in Costa Rica?
Your answer should be compact. 4.64. In the year 2000, what is the difference between the Value added (% of GDP) in Caribbean small states and Value added (% of GDP) in Mauritania?
Keep it short and to the point. 26.35. In the year 2000, what is the difference between the Value added (% of GDP) of Caribbean small states and Value added (% of GDP) of Spain?
Offer a very short reply. -2.04. In the year 2000, what is the difference between the Value added (% of GDP) of Costa Rica and Value added (% of GDP) of Mauritania?
Offer a very short reply. 21.71. In the year 2000, what is the difference between the Value added (% of GDP) in Costa Rica and Value added (% of GDP) in Spain?
Provide a short and direct response. -6.68. In the year 2000, what is the difference between the Value added (% of GDP) of Mauritania and Value added (% of GDP) of Spain?
Your answer should be compact. -28.4. In the year 2001, what is the difference between the Value added (% of GDP) in Caribbean small states and Value added (% of GDP) in Costa Rica?
Offer a very short reply. 3.66. In the year 2001, what is the difference between the Value added (% of GDP) of Caribbean small states and Value added (% of GDP) of Mauritania?
Offer a very short reply. 27.77. In the year 2001, what is the difference between the Value added (% of GDP) in Caribbean small states and Value added (% of GDP) in Spain?
Your response must be concise. -0.23. In the year 2001, what is the difference between the Value added (% of GDP) in Costa Rica and Value added (% of GDP) in Mauritania?
Give a very brief answer. 24.11. In the year 2001, what is the difference between the Value added (% of GDP) in Costa Rica and Value added (% of GDP) in Spain?
Your response must be concise. -3.9. In the year 2001, what is the difference between the Value added (% of GDP) of Mauritania and Value added (% of GDP) of Spain?
Provide a succinct answer. -28.01. In the year 2002, what is the difference between the Value added (% of GDP) of Caribbean small states and Value added (% of GDP) of Costa Rica?
Provide a succinct answer. 3.51. In the year 2002, what is the difference between the Value added (% of GDP) in Caribbean small states and Value added (% of GDP) in Mauritania?
Keep it short and to the point. 25.77. In the year 2002, what is the difference between the Value added (% of GDP) of Caribbean small states and Value added (% of GDP) of Spain?
Your answer should be compact. 0.17. In the year 2002, what is the difference between the Value added (% of GDP) of Costa Rica and Value added (% of GDP) of Mauritania?
Keep it short and to the point. 22.26. In the year 2002, what is the difference between the Value added (% of GDP) in Costa Rica and Value added (% of GDP) in Spain?
Your answer should be compact. -3.34. In the year 2002, what is the difference between the Value added (% of GDP) of Mauritania and Value added (% of GDP) of Spain?
Keep it short and to the point. -25.6. In the year 2003, what is the difference between the Value added (% of GDP) of Caribbean small states and Value added (% of GDP) of Costa Rica?
Provide a succinct answer. 0.56. In the year 2003, what is the difference between the Value added (% of GDP) of Caribbean small states and Value added (% of GDP) of Mauritania?
Make the answer very short. 23. In the year 2003, what is the difference between the Value added (% of GDP) in Caribbean small states and Value added (% of GDP) in Spain?
Offer a terse response. -2.75. In the year 2003, what is the difference between the Value added (% of GDP) of Costa Rica and Value added (% of GDP) of Mauritania?
Offer a terse response. 22.44. In the year 2003, what is the difference between the Value added (% of GDP) of Costa Rica and Value added (% of GDP) of Spain?
Your answer should be very brief. -3.31. In the year 2003, what is the difference between the Value added (% of GDP) of Mauritania and Value added (% of GDP) of Spain?
Make the answer very short. -25.75. What is the ratio of the Value added (% of GDP) of Caribbean small states in 1996 to that in 1997?
Your answer should be compact. 0.98. What is the ratio of the Value added (% of GDP) in Costa Rica in 1996 to that in 1997?
Your response must be concise. 1. What is the ratio of the Value added (% of GDP) of Mauritania in 1996 to that in 1997?
Provide a short and direct response. 0.95. What is the ratio of the Value added (% of GDP) of Caribbean small states in 1996 to that in 1998?
Keep it short and to the point. 0.92. What is the ratio of the Value added (% of GDP) in Costa Rica in 1996 to that in 1998?
Your response must be concise. 1.01. What is the ratio of the Value added (% of GDP) of Mauritania in 1996 to that in 1998?
Ensure brevity in your answer.  1.09. What is the ratio of the Value added (% of GDP) of Spain in 1996 to that in 1998?
Your answer should be compact. 1. What is the ratio of the Value added (% of GDP) in Caribbean small states in 1996 to that in 1999?
Offer a very short reply. 0.93. What is the ratio of the Value added (% of GDP) of Costa Rica in 1996 to that in 1999?
Offer a very short reply. 1.07. What is the ratio of the Value added (% of GDP) in Mauritania in 1996 to that in 1999?
Provide a short and direct response. 1.1. What is the ratio of the Value added (% of GDP) of Spain in 1996 to that in 1999?
Your answer should be very brief. 1. What is the ratio of the Value added (% of GDP) in Caribbean small states in 1996 to that in 2000?
Make the answer very short. 0.96. What is the ratio of the Value added (% of GDP) of Costa Rica in 1996 to that in 2000?
Provide a succinct answer. 0.99. What is the ratio of the Value added (% of GDP) of Mauritania in 1996 to that in 2000?
Offer a very short reply. 1.04. What is the ratio of the Value added (% of GDP) of Caribbean small states in 1996 to that in 2001?
Your answer should be very brief. 0.93. What is the ratio of the Value added (% of GDP) in Costa Rica in 1996 to that in 2001?
Provide a succinct answer. 0.95. What is the ratio of the Value added (% of GDP) of Mauritania in 1996 to that in 2001?
Make the answer very short. 1.03. What is the ratio of the Value added (% of GDP) of Caribbean small states in 1996 to that in 2002?
Provide a short and direct response. 0.92. What is the ratio of the Value added (% of GDP) of Costa Rica in 1996 to that in 2002?
Provide a succinct answer. 0.93. What is the ratio of the Value added (% of GDP) of Mauritania in 1996 to that in 2002?
Provide a short and direct response. 0.96. What is the ratio of the Value added (% of GDP) in Spain in 1996 to that in 2002?
Your answer should be very brief. 0.99. What is the ratio of the Value added (% of GDP) in Caribbean small states in 1996 to that in 2003?
Offer a terse response. 0.95. What is the ratio of the Value added (% of GDP) of Costa Rica in 1996 to that in 2003?
Make the answer very short. 0.93. What is the ratio of the Value added (% of GDP) in Mauritania in 1996 to that in 2003?
Offer a very short reply. 0.95. What is the ratio of the Value added (% of GDP) in Spain in 1996 to that in 2003?
Give a very brief answer. 0.98. What is the ratio of the Value added (% of GDP) of Caribbean small states in 1997 to that in 1998?
Give a very brief answer. 0.94. What is the ratio of the Value added (% of GDP) in Costa Rica in 1997 to that in 1998?
Provide a short and direct response. 1.01. What is the ratio of the Value added (% of GDP) in Mauritania in 1997 to that in 1998?
Provide a succinct answer. 1.14. What is the ratio of the Value added (% of GDP) in Caribbean small states in 1997 to that in 1999?
Give a very brief answer. 0.95. What is the ratio of the Value added (% of GDP) in Costa Rica in 1997 to that in 1999?
Provide a short and direct response. 1.07. What is the ratio of the Value added (% of GDP) in Mauritania in 1997 to that in 1999?
Offer a terse response. 1.15. What is the ratio of the Value added (% of GDP) of Spain in 1997 to that in 1999?
Offer a terse response. 1. What is the ratio of the Value added (% of GDP) in Caribbean small states in 1997 to that in 2000?
Your response must be concise. 0.97. What is the ratio of the Value added (% of GDP) in Costa Rica in 1997 to that in 2000?
Offer a terse response. 0.99. What is the ratio of the Value added (% of GDP) of Mauritania in 1997 to that in 2000?
Your answer should be compact. 1.09. What is the ratio of the Value added (% of GDP) in Spain in 1997 to that in 2000?
Provide a short and direct response. 0.99. What is the ratio of the Value added (% of GDP) in Caribbean small states in 1997 to that in 2001?
Your answer should be very brief. 0.94. What is the ratio of the Value added (% of GDP) in Costa Rica in 1997 to that in 2001?
Keep it short and to the point. 0.95. What is the ratio of the Value added (% of GDP) of Mauritania in 1997 to that in 2001?
Ensure brevity in your answer.  1.08. What is the ratio of the Value added (% of GDP) in Caribbean small states in 1997 to that in 2002?
Your answer should be compact. 0.93. What is the ratio of the Value added (% of GDP) in Costa Rica in 1997 to that in 2002?
Keep it short and to the point. 0.93. What is the ratio of the Value added (% of GDP) in Spain in 1997 to that in 2002?
Keep it short and to the point. 0.99. What is the ratio of the Value added (% of GDP) in Caribbean small states in 1997 to that in 2003?
Your answer should be compact. 0.97. What is the ratio of the Value added (% of GDP) in Costa Rica in 1997 to that in 2003?
Keep it short and to the point. 0.93. What is the ratio of the Value added (% of GDP) of Mauritania in 1997 to that in 2003?
Give a very brief answer. 1. What is the ratio of the Value added (% of GDP) of Spain in 1997 to that in 2003?
Make the answer very short. 0.98. What is the ratio of the Value added (% of GDP) of Caribbean small states in 1998 to that in 1999?
Keep it short and to the point. 1. What is the ratio of the Value added (% of GDP) in Costa Rica in 1998 to that in 1999?
Your response must be concise. 1.06. What is the ratio of the Value added (% of GDP) in Caribbean small states in 1998 to that in 2000?
Your answer should be compact. 1.03. What is the ratio of the Value added (% of GDP) of Costa Rica in 1998 to that in 2000?
Your response must be concise. 0.98. What is the ratio of the Value added (% of GDP) of Mauritania in 1998 to that in 2000?
Give a very brief answer. 0.96. What is the ratio of the Value added (% of GDP) in Caribbean small states in 1998 to that in 2001?
Provide a succinct answer. 1. What is the ratio of the Value added (% of GDP) of Costa Rica in 1998 to that in 2001?
Offer a very short reply. 0.93. What is the ratio of the Value added (% of GDP) of Mauritania in 1998 to that in 2001?
Your answer should be very brief. 0.95. What is the ratio of the Value added (% of GDP) of Spain in 1998 to that in 2001?
Provide a succinct answer. 0.99. What is the ratio of the Value added (% of GDP) of Costa Rica in 1998 to that in 2002?
Ensure brevity in your answer.  0.92. What is the ratio of the Value added (% of GDP) in Caribbean small states in 1998 to that in 2003?
Provide a succinct answer. 1.03. What is the ratio of the Value added (% of GDP) in Costa Rica in 1998 to that in 2003?
Give a very brief answer. 0.92. What is the ratio of the Value added (% of GDP) of Mauritania in 1998 to that in 2003?
Your answer should be compact. 0.88. What is the ratio of the Value added (% of GDP) in Spain in 1998 to that in 2003?
Keep it short and to the point. 0.98. What is the ratio of the Value added (% of GDP) of Caribbean small states in 1999 to that in 2000?
Your response must be concise. 1.03. What is the ratio of the Value added (% of GDP) in Costa Rica in 1999 to that in 2000?
Provide a succinct answer. 0.93. What is the ratio of the Value added (% of GDP) in Mauritania in 1999 to that in 2000?
Keep it short and to the point. 0.95. What is the ratio of the Value added (% of GDP) of Costa Rica in 1999 to that in 2001?
Your answer should be compact. 0.88. What is the ratio of the Value added (% of GDP) in Mauritania in 1999 to that in 2001?
Ensure brevity in your answer.  0.94. What is the ratio of the Value added (% of GDP) in Caribbean small states in 1999 to that in 2002?
Provide a short and direct response. 0.99. What is the ratio of the Value added (% of GDP) of Costa Rica in 1999 to that in 2002?
Keep it short and to the point. 0.87. What is the ratio of the Value added (% of GDP) in Mauritania in 1999 to that in 2002?
Make the answer very short. 0.87. What is the ratio of the Value added (% of GDP) of Spain in 1999 to that in 2002?
Ensure brevity in your answer.  0.99. What is the ratio of the Value added (% of GDP) of Caribbean small states in 1999 to that in 2003?
Give a very brief answer. 1.03. What is the ratio of the Value added (% of GDP) in Costa Rica in 1999 to that in 2003?
Offer a terse response. 0.87. What is the ratio of the Value added (% of GDP) of Mauritania in 1999 to that in 2003?
Ensure brevity in your answer.  0.87. What is the ratio of the Value added (% of GDP) of Spain in 1999 to that in 2003?
Offer a very short reply. 0.99. What is the ratio of the Value added (% of GDP) of Caribbean small states in 2000 to that in 2001?
Offer a very short reply. 0.97. What is the ratio of the Value added (% of GDP) of Costa Rica in 2000 to that in 2001?
Ensure brevity in your answer.  0.95. What is the ratio of the Value added (% of GDP) of Mauritania in 2000 to that in 2001?
Your answer should be compact. 0.98. What is the ratio of the Value added (% of GDP) of Spain in 2000 to that in 2001?
Keep it short and to the point. 1. What is the ratio of the Value added (% of GDP) of Caribbean small states in 2000 to that in 2002?
Your answer should be very brief. 0.96. What is the ratio of the Value added (% of GDP) of Costa Rica in 2000 to that in 2002?
Your answer should be very brief. 0.94. What is the ratio of the Value added (% of GDP) in Mauritania in 2000 to that in 2002?
Provide a succinct answer. 0.92. What is the ratio of the Value added (% of GDP) in Costa Rica in 2000 to that in 2003?
Your answer should be very brief. 0.93. What is the ratio of the Value added (% of GDP) of Mauritania in 2000 to that in 2003?
Provide a succinct answer. 0.91. What is the ratio of the Value added (% of GDP) in Spain in 2000 to that in 2003?
Give a very brief answer. 0.99. What is the ratio of the Value added (% of GDP) in Caribbean small states in 2001 to that in 2002?
Give a very brief answer. 0.99. What is the ratio of the Value added (% of GDP) in Costa Rica in 2001 to that in 2002?
Your response must be concise. 0.99. What is the ratio of the Value added (% of GDP) in Caribbean small states in 2001 to that in 2003?
Your answer should be compact. 1.03. What is the ratio of the Value added (% of GDP) of Costa Rica in 2001 to that in 2003?
Give a very brief answer. 0.98. What is the ratio of the Value added (% of GDP) in Mauritania in 2001 to that in 2003?
Keep it short and to the point. 0.93. What is the ratio of the Value added (% of GDP) in Spain in 2001 to that in 2003?
Your answer should be very brief. 0.99. What is the ratio of the Value added (% of GDP) of Caribbean small states in 2002 to that in 2003?
Your response must be concise. 1.04. What is the ratio of the Value added (% of GDP) of Costa Rica in 2002 to that in 2003?
Ensure brevity in your answer.  1. What is the ratio of the Value added (% of GDP) of Spain in 2002 to that in 2003?
Keep it short and to the point. 1. What is the difference between the highest and the second highest Value added (% of GDP) of Caribbean small states?
Make the answer very short. 0.65. What is the difference between the highest and the second highest Value added (% of GDP) of Costa Rica?
Your response must be concise. 0.26. What is the difference between the highest and the second highest Value added (% of GDP) in Mauritania?
Keep it short and to the point. 0.01. What is the difference between the highest and the second highest Value added (% of GDP) in Spain?
Make the answer very short. 0.23. What is the difference between the highest and the lowest Value added (% of GDP) in Caribbean small states?
Give a very brief answer. 5.55. What is the difference between the highest and the lowest Value added (% of GDP) in Costa Rica?
Provide a short and direct response. 8.28. What is the difference between the highest and the lowest Value added (% of GDP) in Mauritania?
Your answer should be compact. 5.25. What is the difference between the highest and the lowest Value added (% of GDP) of Spain?
Offer a terse response. 1.17. 